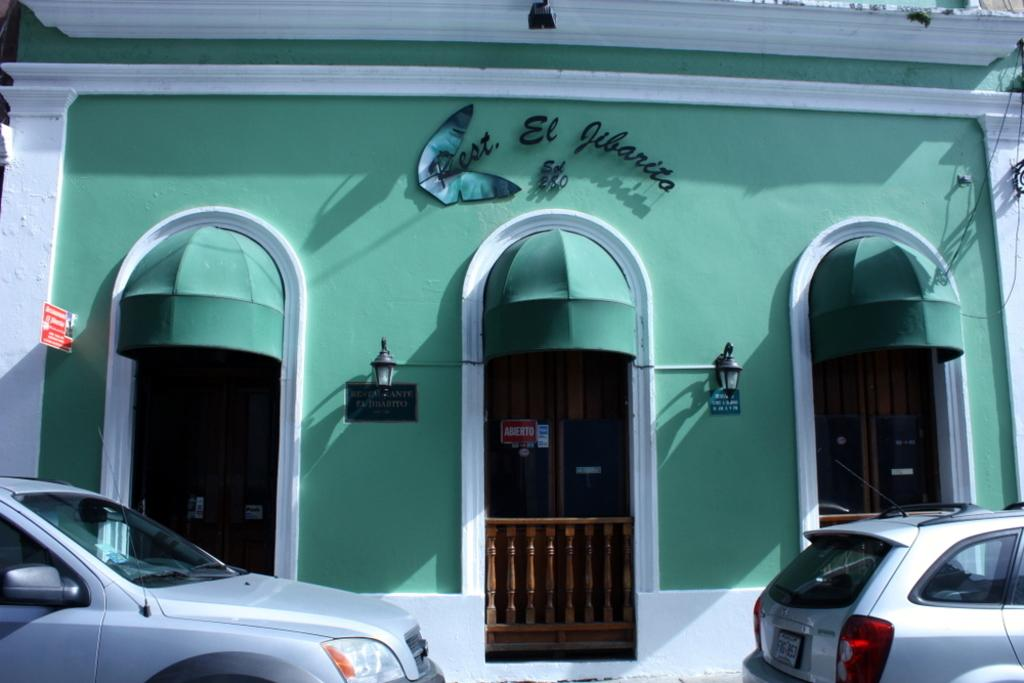What types of objects can be seen in the image? There are vehicles, doors, name boards, lamps, a building, and a fence in the image. Can you describe the vehicles in the image? The vehicles in the image are not specified, so we cannot provide a detailed description. What purpose might the name boards serve in the image? The name boards in the image might serve to identify or label specific areas or locations. How many lamps are visible in the image? The number of lamps in the image is not specified, so we cannot provide an exact count. What is the general setting of the image? The image features a building, a fence, and various objects, suggesting an outdoor or semi-outdoor setting. What type of print can be seen on the fork in the image? There is no fork present in the image, so it is not possible to answer that question. 